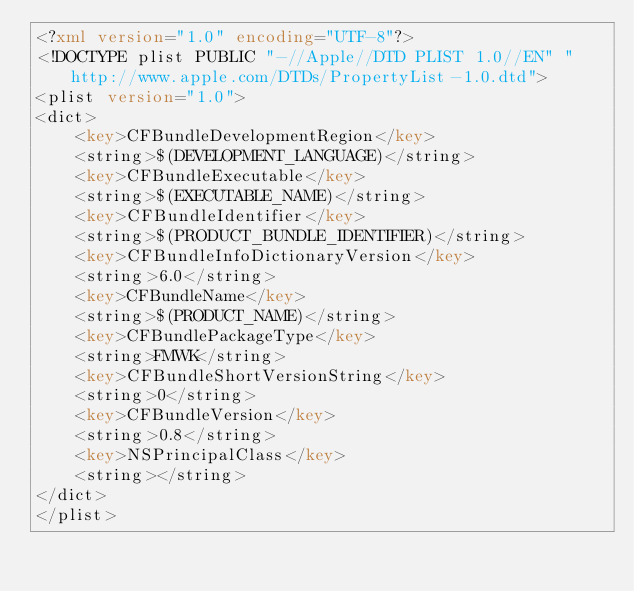<code> <loc_0><loc_0><loc_500><loc_500><_XML_><?xml version="1.0" encoding="UTF-8"?>
<!DOCTYPE plist PUBLIC "-//Apple//DTD PLIST 1.0//EN" "http://www.apple.com/DTDs/PropertyList-1.0.dtd">
<plist version="1.0">
<dict>
	<key>CFBundleDevelopmentRegion</key>
	<string>$(DEVELOPMENT_LANGUAGE)</string>
	<key>CFBundleExecutable</key>
	<string>$(EXECUTABLE_NAME)</string>
	<key>CFBundleIdentifier</key>
	<string>$(PRODUCT_BUNDLE_IDENTIFIER)</string>
	<key>CFBundleInfoDictionaryVersion</key>
	<string>6.0</string>
	<key>CFBundleName</key>
	<string>$(PRODUCT_NAME)</string>
	<key>CFBundlePackageType</key>
	<string>FMWK</string>
	<key>CFBundleShortVersionString</key>
	<string>0</string>
	<key>CFBundleVersion</key>
	<string>0.8</string>
	<key>NSPrincipalClass</key>
	<string></string>
</dict>
</plist>
</code> 